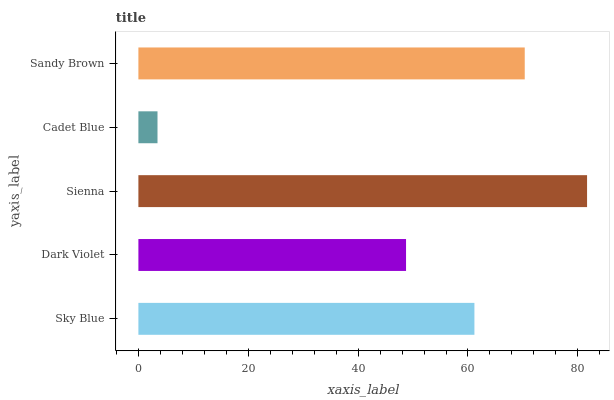Is Cadet Blue the minimum?
Answer yes or no. Yes. Is Sienna the maximum?
Answer yes or no. Yes. Is Dark Violet the minimum?
Answer yes or no. No. Is Dark Violet the maximum?
Answer yes or no. No. Is Sky Blue greater than Dark Violet?
Answer yes or no. Yes. Is Dark Violet less than Sky Blue?
Answer yes or no. Yes. Is Dark Violet greater than Sky Blue?
Answer yes or no. No. Is Sky Blue less than Dark Violet?
Answer yes or no. No. Is Sky Blue the high median?
Answer yes or no. Yes. Is Sky Blue the low median?
Answer yes or no. Yes. Is Cadet Blue the high median?
Answer yes or no. No. Is Sienna the low median?
Answer yes or no. No. 